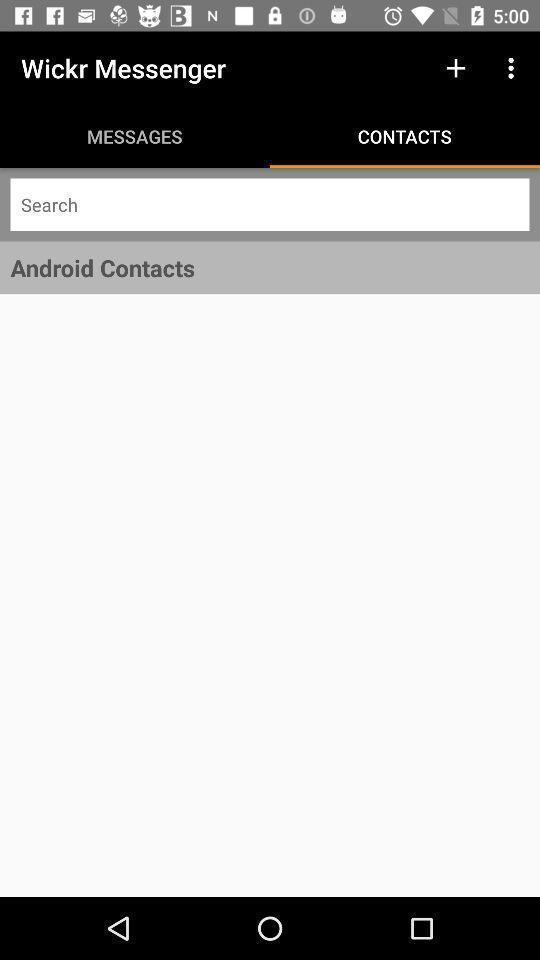What can you discern from this picture? Screen display contacts page of a social media app. 